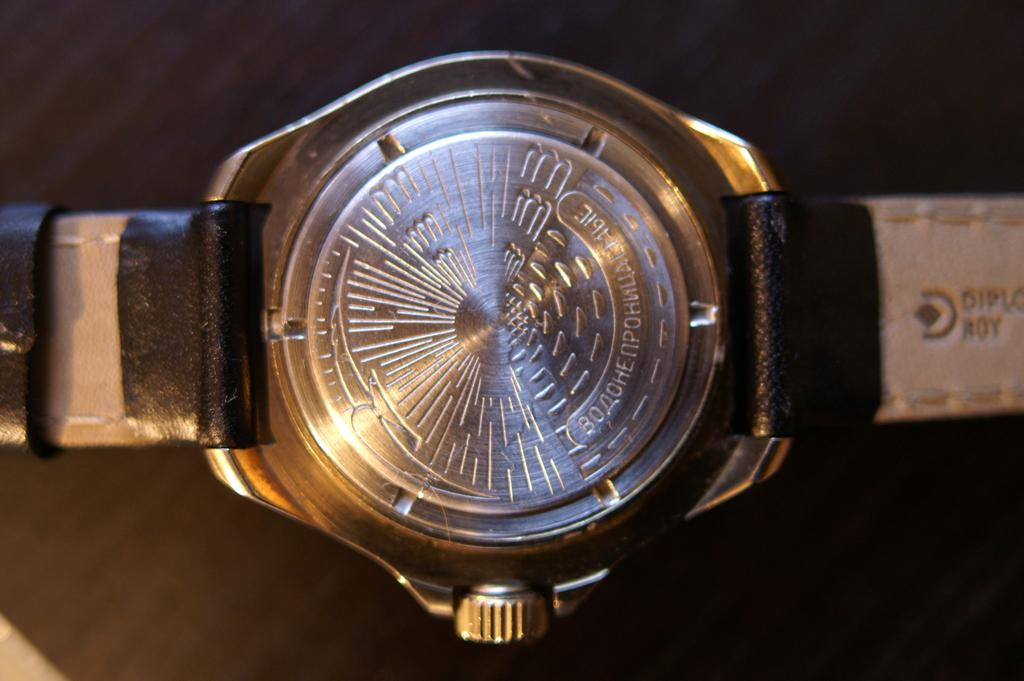What is the main subject of the image? The main subject of the image is the backside of a watch. What can be seen on the watch? There is writing on the watch. How many frogs are jumping in the alley in the image? There are no frogs or alleys present in the image; it features the backside of a watch with writing on it. 